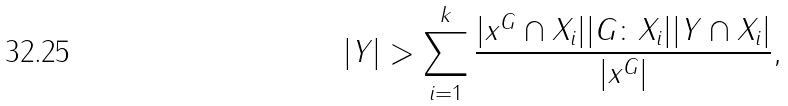<formula> <loc_0><loc_0><loc_500><loc_500>| Y | > \sum _ { i = 1 } ^ { k } \frac { | x ^ { G } \cap X _ { i } | | G \colon X _ { i } | | Y \cap X _ { i } | } { | x ^ { G } | } ,</formula> 